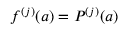<formula> <loc_0><loc_0><loc_500><loc_500>f ^ { ( j ) } ( a ) = P ^ { ( j ) } ( a )</formula> 